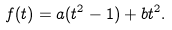<formula> <loc_0><loc_0><loc_500><loc_500>f ( t ) = a ( t ^ { 2 } - 1 ) + b t ^ { 2 } .</formula> 